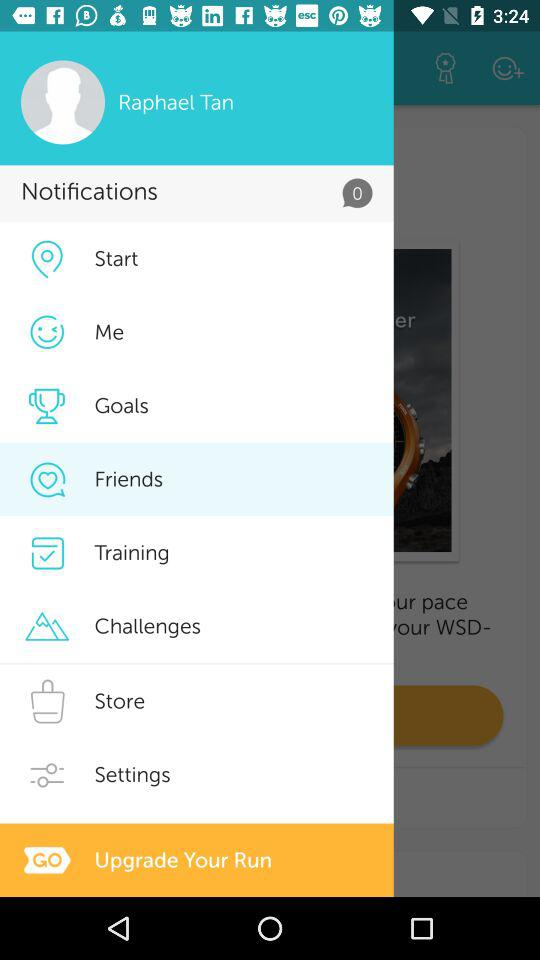How many notifications are there? There are 0 notifications. 